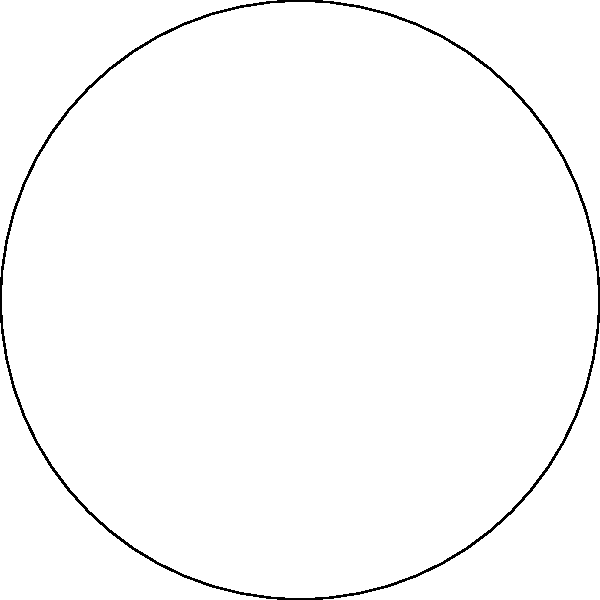In the fight against corporate influence, understanding alternative perspectives is crucial. Consider the spherical triangle shown above, with angles $\alpha$, $\beta$, and $\gamma$. If the sum of these angles is 270°, how does this compare to the sum of angles in a Euclidean triangle, and what might this difference symbolize in terms of challenging traditional corporate-friendly economic models? To understand the difference between spherical and Euclidean triangles:

1) In Euclidean geometry, the sum of angles in a triangle is always 180°.

2) In spherical geometry, the sum of angles in a triangle is always greater than 180° and less than 540°.

3) The exact sum depends on the area of the spherical triangle.

4) In this case, we're given that $\alpha + \beta + \gamma = 270°$.

5) The difference between the spherical and Euclidean sums is:
   $270° - 180° = 90°$

This 90° difference, or "excess", is directly proportional to the area of the spherical triangle.

Symbolically, this could represent:
- The need to think beyond traditional "flat" economic models
- The interconnectedness of global economics (as on a sphere)
- The "excess" could symbolize untapped resources or unfair advantages that corporations exploit

The non-Euclidean nature challenges us to think outside conventional frameworks, much like how progressive policies often challenge traditional corporate-friendly economic models.
Answer: 90° more than Euclidean; symbolizes need for non-traditional economic thinking 